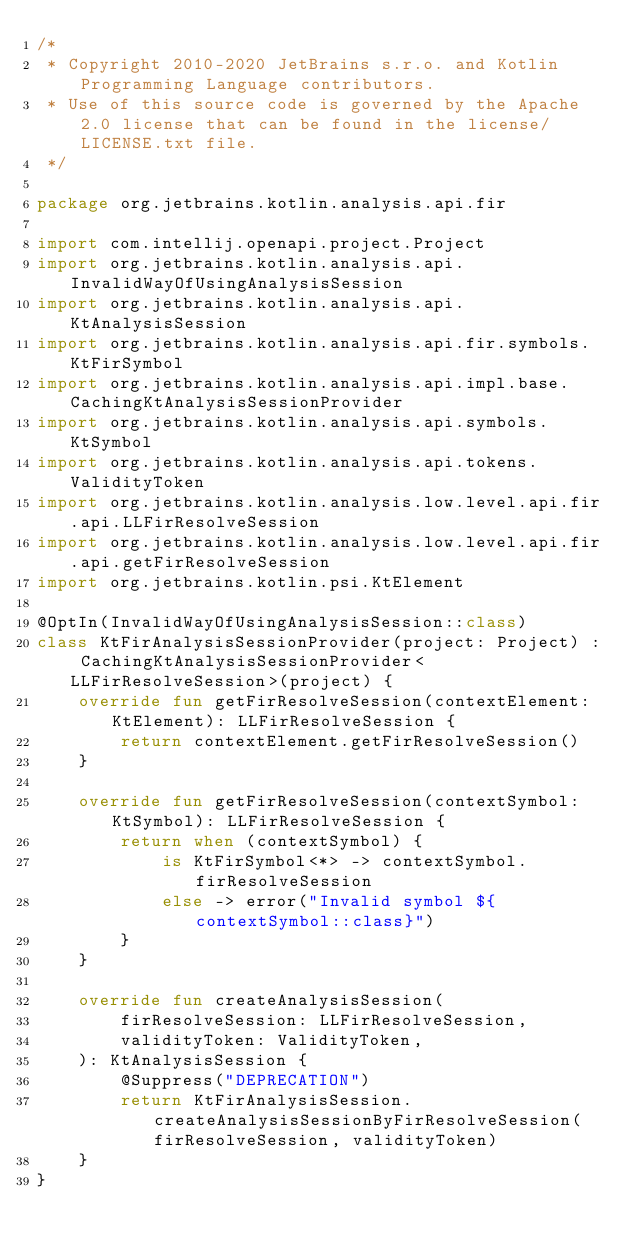Convert code to text. <code><loc_0><loc_0><loc_500><loc_500><_Kotlin_>/*
 * Copyright 2010-2020 JetBrains s.r.o. and Kotlin Programming Language contributors.
 * Use of this source code is governed by the Apache 2.0 license that can be found in the license/LICENSE.txt file.
 */

package org.jetbrains.kotlin.analysis.api.fir

import com.intellij.openapi.project.Project
import org.jetbrains.kotlin.analysis.api.InvalidWayOfUsingAnalysisSession
import org.jetbrains.kotlin.analysis.api.KtAnalysisSession
import org.jetbrains.kotlin.analysis.api.fir.symbols.KtFirSymbol
import org.jetbrains.kotlin.analysis.api.impl.base.CachingKtAnalysisSessionProvider
import org.jetbrains.kotlin.analysis.api.symbols.KtSymbol
import org.jetbrains.kotlin.analysis.api.tokens.ValidityToken
import org.jetbrains.kotlin.analysis.low.level.api.fir.api.LLFirResolveSession
import org.jetbrains.kotlin.analysis.low.level.api.fir.api.getFirResolveSession
import org.jetbrains.kotlin.psi.KtElement

@OptIn(InvalidWayOfUsingAnalysisSession::class)
class KtFirAnalysisSessionProvider(project: Project) : CachingKtAnalysisSessionProvider<LLFirResolveSession>(project) {
    override fun getFirResolveSession(contextElement: KtElement): LLFirResolveSession {
        return contextElement.getFirResolveSession()
    }

    override fun getFirResolveSession(contextSymbol: KtSymbol): LLFirResolveSession {
        return when (contextSymbol) {
            is KtFirSymbol<*> -> contextSymbol.firResolveSession
            else -> error("Invalid symbol ${contextSymbol::class}")
        }
    }

    override fun createAnalysisSession(
        firResolveSession: LLFirResolveSession,
        validityToken: ValidityToken,
    ): KtAnalysisSession {
        @Suppress("DEPRECATION")
        return KtFirAnalysisSession.createAnalysisSessionByFirResolveSession(firResolveSession, validityToken)
    }
}


</code> 